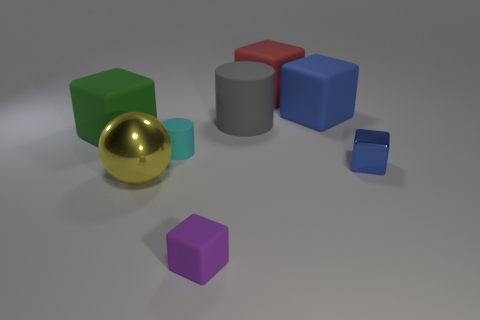Subtract 1 cubes. How many cubes are left? 4 Subtract all purple cubes. How many cubes are left? 4 Subtract all purple blocks. How many blocks are left? 4 Subtract all red cubes. Subtract all red spheres. How many cubes are left? 4 Add 1 yellow objects. How many objects exist? 9 Subtract all spheres. How many objects are left? 7 Subtract all big yellow metallic things. Subtract all big cylinders. How many objects are left? 6 Add 2 tiny metal blocks. How many tiny metal blocks are left? 3 Add 2 shiny cubes. How many shiny cubes exist? 3 Subtract 0 yellow blocks. How many objects are left? 8 